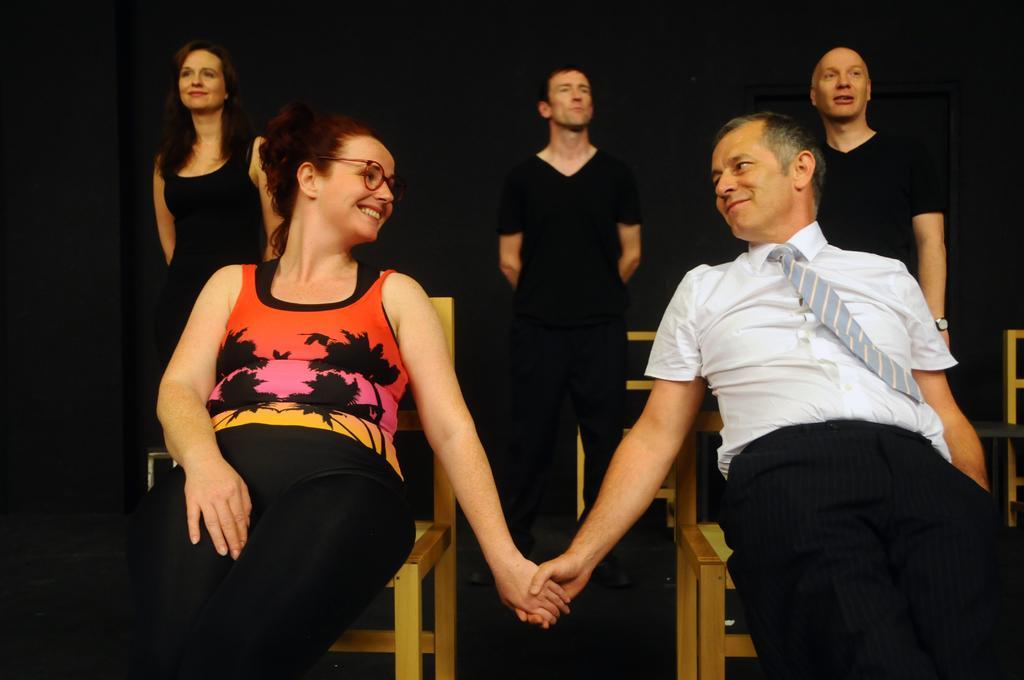Describe this image in one or two sentences. In this image I can see two people sitting on the chairs and wearing the different color dresses. In the background I can see few people standing and wearing the black color dresses and there are few more chairs. And there is a black background. 